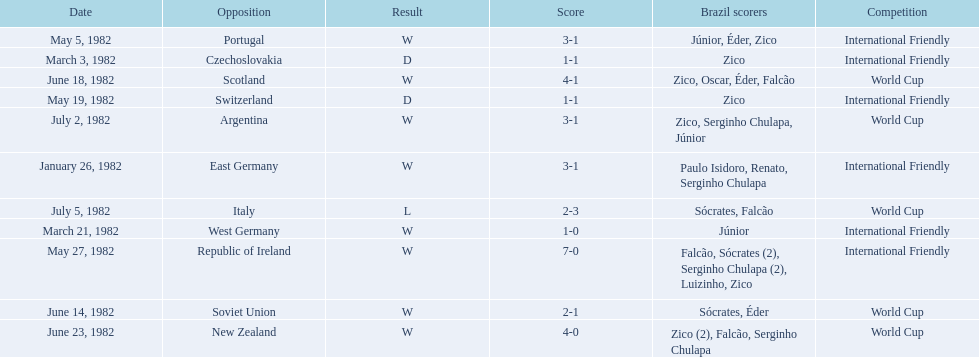How many games did zico end up scoring in during this season? 7. 